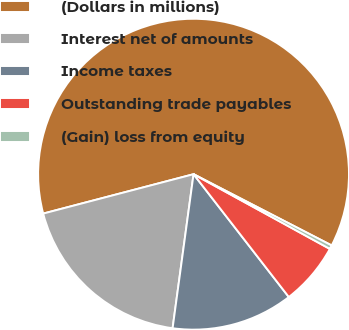<chart> <loc_0><loc_0><loc_500><loc_500><pie_chart><fcel>(Dollars in millions)<fcel>Interest net of amounts<fcel>Income taxes<fcel>Outstanding trade payables<fcel>(Gain) loss from equity<nl><fcel>61.65%<fcel>18.77%<fcel>12.65%<fcel>6.52%<fcel>0.4%<nl></chart> 